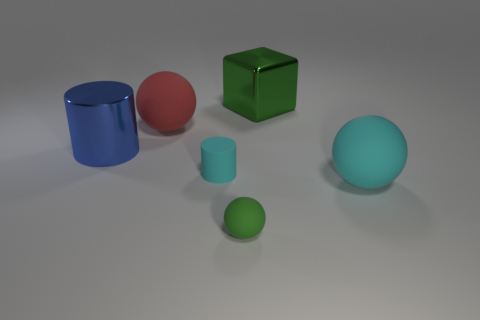What is the material of the tiny object that is the same color as the big metallic cube?
Ensure brevity in your answer.  Rubber. Are there any other things that have the same material as the large blue cylinder?
Your response must be concise. Yes. There is a red rubber object; what shape is it?
Offer a very short reply. Sphere. What shape is the shiny thing that is the same size as the green block?
Offer a terse response. Cylinder. Is there any other thing that has the same color as the large cube?
Provide a short and direct response. Yes. There is a red thing that is made of the same material as the tiny sphere; what is its size?
Provide a succinct answer. Large. Is the shape of the small cyan matte thing the same as the small thing that is in front of the tiny cyan rubber thing?
Offer a terse response. No. The red rubber sphere is what size?
Provide a short and direct response. Large. Is the number of green shiny blocks that are on the left side of the metal cube less than the number of red balls?
Ensure brevity in your answer.  Yes. How many blue metallic cylinders have the same size as the green cube?
Your answer should be very brief. 1. 